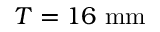Convert formula to latex. <formula><loc_0><loc_0><loc_500><loc_500>T = 1 6 \ { m m }</formula> 